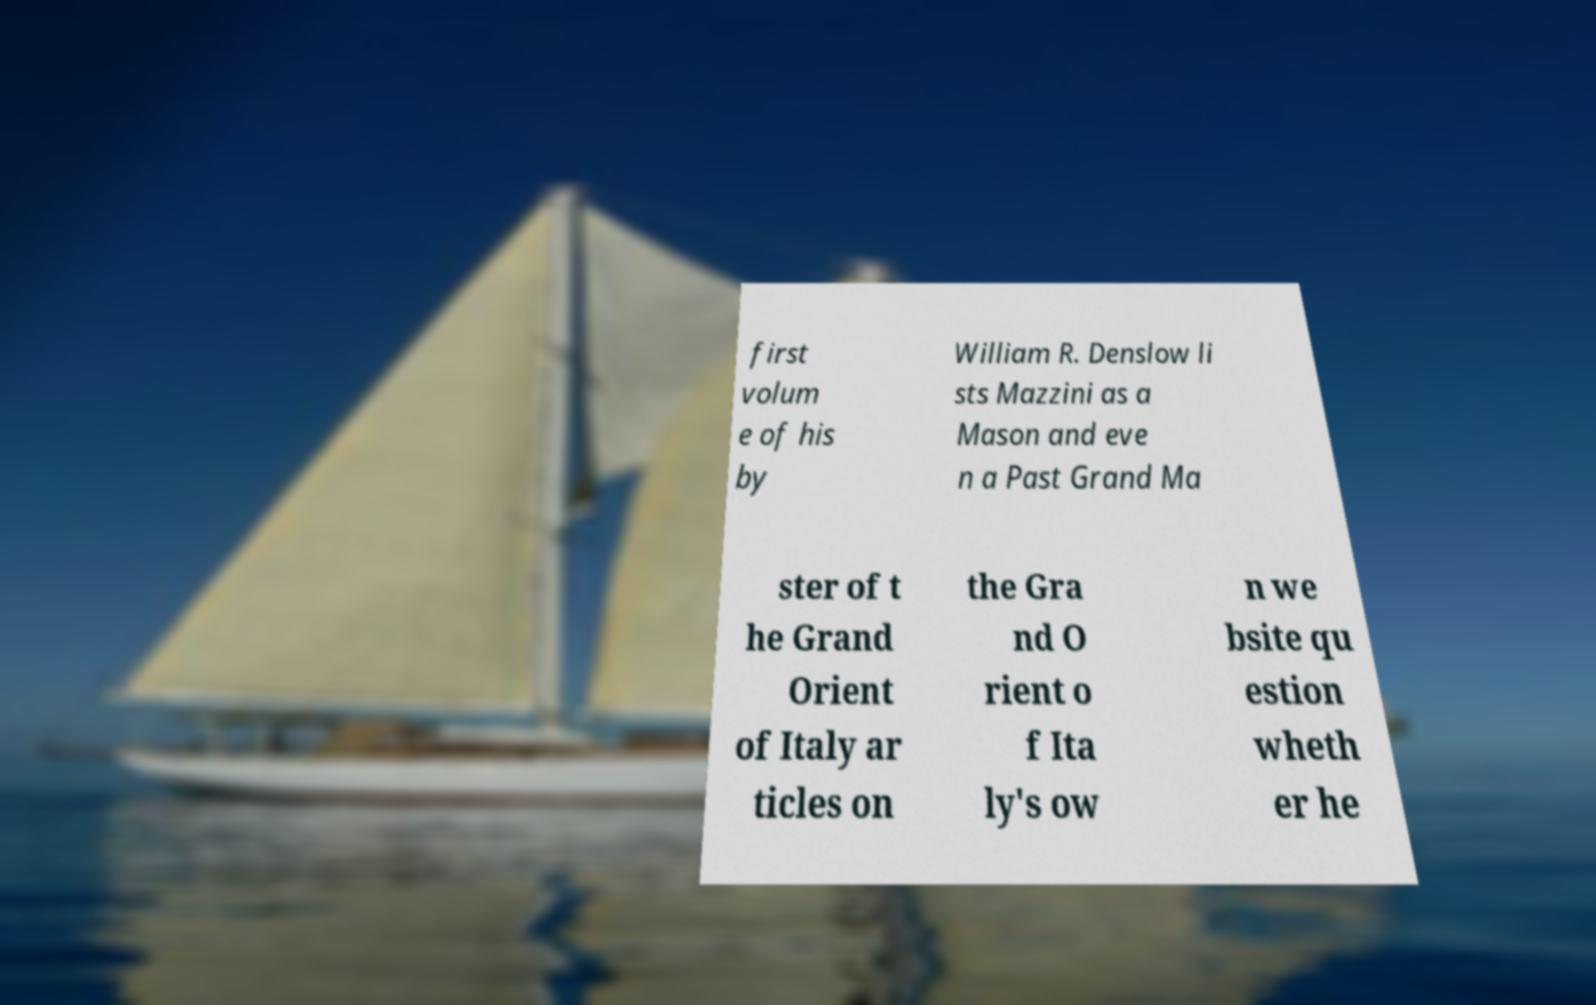Can you accurately transcribe the text from the provided image for me? first volum e of his by William R. Denslow li sts Mazzini as a Mason and eve n a Past Grand Ma ster of t he Grand Orient of Italy ar ticles on the Gra nd O rient o f Ita ly's ow n we bsite qu estion wheth er he 